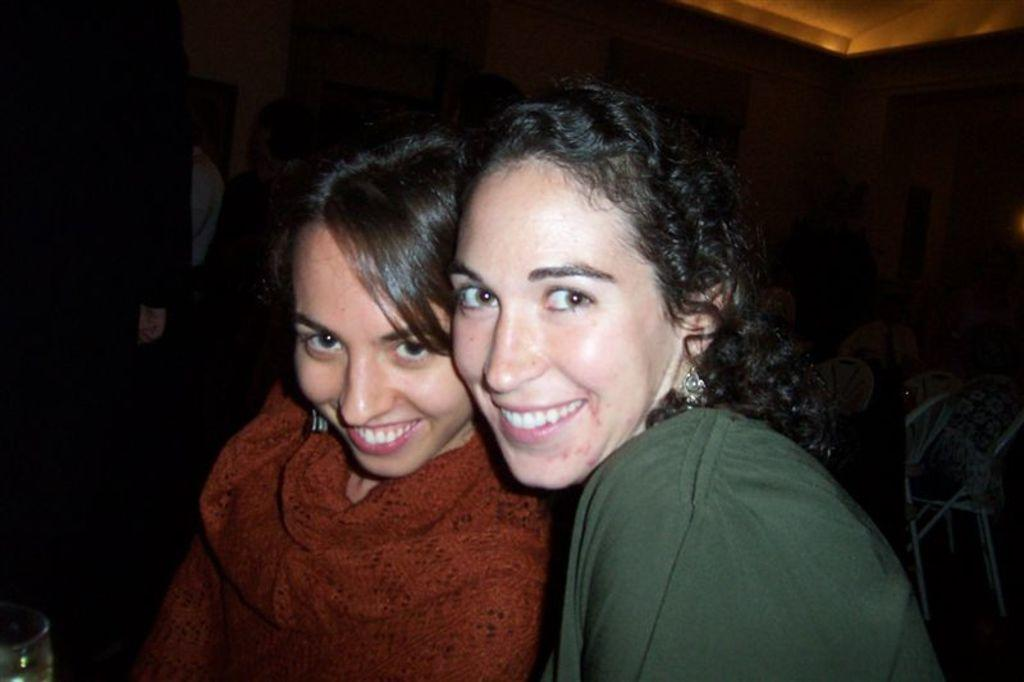How many women are in the image? There are two women in the image. What colors are the dresses worn by the women? One woman is wearing a green dress, and the other woman is wearing a maroon dress. What expressions do the women have in the image? Both women are smiling. What can be said about the background of the image? The background of the image is dark. What type of quilt is being used as a drum in the image? There is no quilt or drum present in the image. 